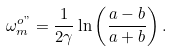<formula> <loc_0><loc_0><loc_500><loc_500>\omega _ { m } ^ { o " } = \frac { 1 } { 2 \gamma } \ln \left ( \frac { a - b } { a + b } \right ) .</formula> 